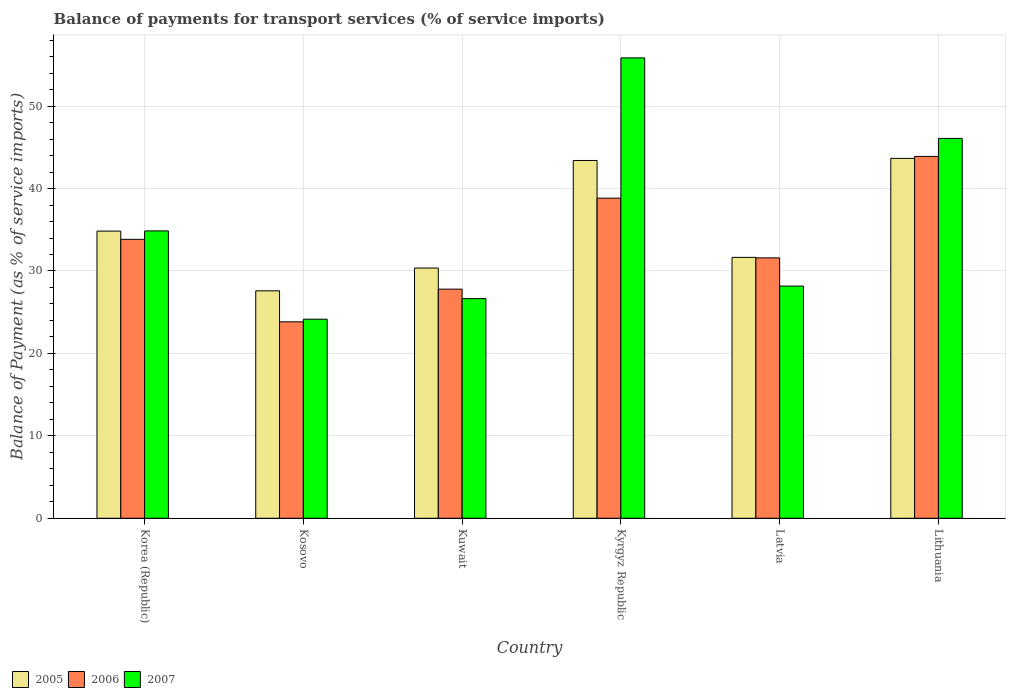How many different coloured bars are there?
Give a very brief answer. 3. Are the number of bars on each tick of the X-axis equal?
Give a very brief answer. Yes. How many bars are there on the 4th tick from the left?
Keep it short and to the point. 3. What is the label of the 5th group of bars from the left?
Make the answer very short. Latvia. What is the balance of payments for transport services in 2007 in Lithuania?
Offer a terse response. 46.08. Across all countries, what is the maximum balance of payments for transport services in 2006?
Your answer should be very brief. 43.9. Across all countries, what is the minimum balance of payments for transport services in 2005?
Give a very brief answer. 27.59. In which country was the balance of payments for transport services in 2005 maximum?
Your answer should be very brief. Lithuania. In which country was the balance of payments for transport services in 2005 minimum?
Make the answer very short. Kosovo. What is the total balance of payments for transport services in 2006 in the graph?
Offer a terse response. 199.79. What is the difference between the balance of payments for transport services in 2005 in Kosovo and that in Latvia?
Provide a succinct answer. -4.06. What is the difference between the balance of payments for transport services in 2005 in Kyrgyz Republic and the balance of payments for transport services in 2007 in Kuwait?
Your answer should be compact. 16.76. What is the average balance of payments for transport services in 2007 per country?
Keep it short and to the point. 35.96. What is the difference between the balance of payments for transport services of/in 2005 and balance of payments for transport services of/in 2007 in Kuwait?
Provide a short and direct response. 3.71. In how many countries, is the balance of payments for transport services in 2005 greater than 54 %?
Make the answer very short. 0. What is the ratio of the balance of payments for transport services in 2006 in Kosovo to that in Lithuania?
Your answer should be very brief. 0.54. Is the difference between the balance of payments for transport services in 2005 in Korea (Republic) and Kosovo greater than the difference between the balance of payments for transport services in 2007 in Korea (Republic) and Kosovo?
Your answer should be compact. No. What is the difference between the highest and the second highest balance of payments for transport services in 2006?
Make the answer very short. -10.06. What is the difference between the highest and the lowest balance of payments for transport services in 2005?
Keep it short and to the point. 16.07. What is the difference between two consecutive major ticks on the Y-axis?
Provide a short and direct response. 10. Are the values on the major ticks of Y-axis written in scientific E-notation?
Your answer should be compact. No. Does the graph contain any zero values?
Give a very brief answer. No. Does the graph contain grids?
Your answer should be compact. Yes. How many legend labels are there?
Ensure brevity in your answer.  3. How are the legend labels stacked?
Provide a short and direct response. Horizontal. What is the title of the graph?
Offer a very short reply. Balance of payments for transport services (% of service imports). What is the label or title of the Y-axis?
Give a very brief answer. Balance of Payment (as % of service imports). What is the Balance of Payment (as % of service imports) of 2005 in Korea (Republic)?
Ensure brevity in your answer.  34.84. What is the Balance of Payment (as % of service imports) of 2006 in Korea (Republic)?
Keep it short and to the point. 33.84. What is the Balance of Payment (as % of service imports) in 2007 in Korea (Republic)?
Give a very brief answer. 34.86. What is the Balance of Payment (as % of service imports) of 2005 in Kosovo?
Your answer should be compact. 27.59. What is the Balance of Payment (as % of service imports) of 2006 in Kosovo?
Make the answer very short. 23.83. What is the Balance of Payment (as % of service imports) of 2007 in Kosovo?
Offer a very short reply. 24.15. What is the Balance of Payment (as % of service imports) of 2005 in Kuwait?
Offer a terse response. 30.36. What is the Balance of Payment (as % of service imports) in 2006 in Kuwait?
Provide a succinct answer. 27.8. What is the Balance of Payment (as % of service imports) of 2007 in Kuwait?
Ensure brevity in your answer.  26.65. What is the Balance of Payment (as % of service imports) in 2005 in Kyrgyz Republic?
Offer a very short reply. 43.41. What is the Balance of Payment (as % of service imports) in 2006 in Kyrgyz Republic?
Ensure brevity in your answer.  38.83. What is the Balance of Payment (as % of service imports) of 2007 in Kyrgyz Republic?
Keep it short and to the point. 55.85. What is the Balance of Payment (as % of service imports) in 2005 in Latvia?
Your answer should be compact. 31.65. What is the Balance of Payment (as % of service imports) of 2006 in Latvia?
Make the answer very short. 31.59. What is the Balance of Payment (as % of service imports) of 2007 in Latvia?
Offer a very short reply. 28.17. What is the Balance of Payment (as % of service imports) of 2005 in Lithuania?
Keep it short and to the point. 43.66. What is the Balance of Payment (as % of service imports) in 2006 in Lithuania?
Keep it short and to the point. 43.9. What is the Balance of Payment (as % of service imports) of 2007 in Lithuania?
Give a very brief answer. 46.08. Across all countries, what is the maximum Balance of Payment (as % of service imports) in 2005?
Ensure brevity in your answer.  43.66. Across all countries, what is the maximum Balance of Payment (as % of service imports) in 2006?
Offer a very short reply. 43.9. Across all countries, what is the maximum Balance of Payment (as % of service imports) in 2007?
Your answer should be compact. 55.85. Across all countries, what is the minimum Balance of Payment (as % of service imports) in 2005?
Provide a short and direct response. 27.59. Across all countries, what is the minimum Balance of Payment (as % of service imports) of 2006?
Keep it short and to the point. 23.83. Across all countries, what is the minimum Balance of Payment (as % of service imports) in 2007?
Offer a terse response. 24.15. What is the total Balance of Payment (as % of service imports) of 2005 in the graph?
Provide a succinct answer. 211.51. What is the total Balance of Payment (as % of service imports) in 2006 in the graph?
Your answer should be very brief. 199.79. What is the total Balance of Payment (as % of service imports) of 2007 in the graph?
Provide a succinct answer. 215.76. What is the difference between the Balance of Payment (as % of service imports) of 2005 in Korea (Republic) and that in Kosovo?
Give a very brief answer. 7.24. What is the difference between the Balance of Payment (as % of service imports) of 2006 in Korea (Republic) and that in Kosovo?
Make the answer very short. 10.01. What is the difference between the Balance of Payment (as % of service imports) in 2007 in Korea (Republic) and that in Kosovo?
Ensure brevity in your answer.  10.71. What is the difference between the Balance of Payment (as % of service imports) in 2005 in Korea (Republic) and that in Kuwait?
Provide a short and direct response. 4.48. What is the difference between the Balance of Payment (as % of service imports) of 2006 in Korea (Republic) and that in Kuwait?
Your answer should be very brief. 6.04. What is the difference between the Balance of Payment (as % of service imports) of 2007 in Korea (Republic) and that in Kuwait?
Provide a short and direct response. 8.21. What is the difference between the Balance of Payment (as % of service imports) in 2005 in Korea (Republic) and that in Kyrgyz Republic?
Offer a very short reply. -8.57. What is the difference between the Balance of Payment (as % of service imports) of 2006 in Korea (Republic) and that in Kyrgyz Republic?
Offer a very short reply. -4.99. What is the difference between the Balance of Payment (as % of service imports) in 2007 in Korea (Republic) and that in Kyrgyz Republic?
Provide a succinct answer. -20.99. What is the difference between the Balance of Payment (as % of service imports) in 2005 in Korea (Republic) and that in Latvia?
Offer a very short reply. 3.19. What is the difference between the Balance of Payment (as % of service imports) in 2006 in Korea (Republic) and that in Latvia?
Keep it short and to the point. 2.25. What is the difference between the Balance of Payment (as % of service imports) of 2007 in Korea (Republic) and that in Latvia?
Give a very brief answer. 6.69. What is the difference between the Balance of Payment (as % of service imports) in 2005 in Korea (Republic) and that in Lithuania?
Your answer should be compact. -8.82. What is the difference between the Balance of Payment (as % of service imports) of 2006 in Korea (Republic) and that in Lithuania?
Ensure brevity in your answer.  -10.06. What is the difference between the Balance of Payment (as % of service imports) in 2007 in Korea (Republic) and that in Lithuania?
Provide a short and direct response. -11.22. What is the difference between the Balance of Payment (as % of service imports) of 2005 in Kosovo and that in Kuwait?
Make the answer very short. -2.76. What is the difference between the Balance of Payment (as % of service imports) in 2006 in Kosovo and that in Kuwait?
Ensure brevity in your answer.  -3.96. What is the difference between the Balance of Payment (as % of service imports) in 2007 in Kosovo and that in Kuwait?
Your answer should be compact. -2.5. What is the difference between the Balance of Payment (as % of service imports) of 2005 in Kosovo and that in Kyrgyz Republic?
Offer a terse response. -15.81. What is the difference between the Balance of Payment (as % of service imports) in 2006 in Kosovo and that in Kyrgyz Republic?
Keep it short and to the point. -15. What is the difference between the Balance of Payment (as % of service imports) of 2007 in Kosovo and that in Kyrgyz Republic?
Keep it short and to the point. -31.7. What is the difference between the Balance of Payment (as % of service imports) in 2005 in Kosovo and that in Latvia?
Your response must be concise. -4.06. What is the difference between the Balance of Payment (as % of service imports) in 2006 in Kosovo and that in Latvia?
Offer a very short reply. -7.76. What is the difference between the Balance of Payment (as % of service imports) in 2007 in Kosovo and that in Latvia?
Keep it short and to the point. -4.02. What is the difference between the Balance of Payment (as % of service imports) in 2005 in Kosovo and that in Lithuania?
Your response must be concise. -16.07. What is the difference between the Balance of Payment (as % of service imports) of 2006 in Kosovo and that in Lithuania?
Provide a short and direct response. -20.07. What is the difference between the Balance of Payment (as % of service imports) of 2007 in Kosovo and that in Lithuania?
Provide a succinct answer. -21.93. What is the difference between the Balance of Payment (as % of service imports) of 2005 in Kuwait and that in Kyrgyz Republic?
Give a very brief answer. -13.05. What is the difference between the Balance of Payment (as % of service imports) in 2006 in Kuwait and that in Kyrgyz Republic?
Offer a very short reply. -11.04. What is the difference between the Balance of Payment (as % of service imports) in 2007 in Kuwait and that in Kyrgyz Republic?
Your answer should be very brief. -29.2. What is the difference between the Balance of Payment (as % of service imports) of 2005 in Kuwait and that in Latvia?
Your answer should be compact. -1.29. What is the difference between the Balance of Payment (as % of service imports) in 2006 in Kuwait and that in Latvia?
Ensure brevity in your answer.  -3.79. What is the difference between the Balance of Payment (as % of service imports) of 2007 in Kuwait and that in Latvia?
Provide a short and direct response. -1.52. What is the difference between the Balance of Payment (as % of service imports) of 2005 in Kuwait and that in Lithuania?
Your answer should be compact. -13.3. What is the difference between the Balance of Payment (as % of service imports) of 2006 in Kuwait and that in Lithuania?
Keep it short and to the point. -16.1. What is the difference between the Balance of Payment (as % of service imports) of 2007 in Kuwait and that in Lithuania?
Ensure brevity in your answer.  -19.43. What is the difference between the Balance of Payment (as % of service imports) of 2005 in Kyrgyz Republic and that in Latvia?
Provide a short and direct response. 11.75. What is the difference between the Balance of Payment (as % of service imports) of 2006 in Kyrgyz Republic and that in Latvia?
Offer a terse response. 7.24. What is the difference between the Balance of Payment (as % of service imports) of 2007 in Kyrgyz Republic and that in Latvia?
Provide a succinct answer. 27.68. What is the difference between the Balance of Payment (as % of service imports) of 2005 in Kyrgyz Republic and that in Lithuania?
Offer a terse response. -0.25. What is the difference between the Balance of Payment (as % of service imports) of 2006 in Kyrgyz Republic and that in Lithuania?
Ensure brevity in your answer.  -5.07. What is the difference between the Balance of Payment (as % of service imports) of 2007 in Kyrgyz Republic and that in Lithuania?
Your response must be concise. 9.77. What is the difference between the Balance of Payment (as % of service imports) of 2005 in Latvia and that in Lithuania?
Make the answer very short. -12.01. What is the difference between the Balance of Payment (as % of service imports) in 2006 in Latvia and that in Lithuania?
Your response must be concise. -12.31. What is the difference between the Balance of Payment (as % of service imports) in 2007 in Latvia and that in Lithuania?
Keep it short and to the point. -17.91. What is the difference between the Balance of Payment (as % of service imports) of 2005 in Korea (Republic) and the Balance of Payment (as % of service imports) of 2006 in Kosovo?
Your response must be concise. 11. What is the difference between the Balance of Payment (as % of service imports) of 2005 in Korea (Republic) and the Balance of Payment (as % of service imports) of 2007 in Kosovo?
Ensure brevity in your answer.  10.69. What is the difference between the Balance of Payment (as % of service imports) in 2006 in Korea (Republic) and the Balance of Payment (as % of service imports) in 2007 in Kosovo?
Your response must be concise. 9.69. What is the difference between the Balance of Payment (as % of service imports) in 2005 in Korea (Republic) and the Balance of Payment (as % of service imports) in 2006 in Kuwait?
Your answer should be very brief. 7.04. What is the difference between the Balance of Payment (as % of service imports) in 2005 in Korea (Republic) and the Balance of Payment (as % of service imports) in 2007 in Kuwait?
Your response must be concise. 8.19. What is the difference between the Balance of Payment (as % of service imports) in 2006 in Korea (Republic) and the Balance of Payment (as % of service imports) in 2007 in Kuwait?
Offer a very short reply. 7.19. What is the difference between the Balance of Payment (as % of service imports) in 2005 in Korea (Republic) and the Balance of Payment (as % of service imports) in 2006 in Kyrgyz Republic?
Keep it short and to the point. -3.99. What is the difference between the Balance of Payment (as % of service imports) in 2005 in Korea (Republic) and the Balance of Payment (as % of service imports) in 2007 in Kyrgyz Republic?
Keep it short and to the point. -21.01. What is the difference between the Balance of Payment (as % of service imports) in 2006 in Korea (Republic) and the Balance of Payment (as % of service imports) in 2007 in Kyrgyz Republic?
Your response must be concise. -22.01. What is the difference between the Balance of Payment (as % of service imports) in 2005 in Korea (Republic) and the Balance of Payment (as % of service imports) in 2006 in Latvia?
Ensure brevity in your answer.  3.25. What is the difference between the Balance of Payment (as % of service imports) in 2005 in Korea (Republic) and the Balance of Payment (as % of service imports) in 2007 in Latvia?
Offer a terse response. 6.67. What is the difference between the Balance of Payment (as % of service imports) of 2006 in Korea (Republic) and the Balance of Payment (as % of service imports) of 2007 in Latvia?
Your response must be concise. 5.67. What is the difference between the Balance of Payment (as % of service imports) of 2005 in Korea (Republic) and the Balance of Payment (as % of service imports) of 2006 in Lithuania?
Your answer should be very brief. -9.06. What is the difference between the Balance of Payment (as % of service imports) of 2005 in Korea (Republic) and the Balance of Payment (as % of service imports) of 2007 in Lithuania?
Your answer should be compact. -11.24. What is the difference between the Balance of Payment (as % of service imports) in 2006 in Korea (Republic) and the Balance of Payment (as % of service imports) in 2007 in Lithuania?
Make the answer very short. -12.24. What is the difference between the Balance of Payment (as % of service imports) of 2005 in Kosovo and the Balance of Payment (as % of service imports) of 2006 in Kuwait?
Your answer should be very brief. -0.2. What is the difference between the Balance of Payment (as % of service imports) in 2005 in Kosovo and the Balance of Payment (as % of service imports) in 2007 in Kuwait?
Your answer should be very brief. 0.95. What is the difference between the Balance of Payment (as % of service imports) in 2006 in Kosovo and the Balance of Payment (as % of service imports) in 2007 in Kuwait?
Offer a terse response. -2.81. What is the difference between the Balance of Payment (as % of service imports) of 2005 in Kosovo and the Balance of Payment (as % of service imports) of 2006 in Kyrgyz Republic?
Make the answer very short. -11.24. What is the difference between the Balance of Payment (as % of service imports) of 2005 in Kosovo and the Balance of Payment (as % of service imports) of 2007 in Kyrgyz Republic?
Offer a terse response. -28.26. What is the difference between the Balance of Payment (as % of service imports) of 2006 in Kosovo and the Balance of Payment (as % of service imports) of 2007 in Kyrgyz Republic?
Provide a succinct answer. -32.02. What is the difference between the Balance of Payment (as % of service imports) in 2005 in Kosovo and the Balance of Payment (as % of service imports) in 2006 in Latvia?
Make the answer very short. -4. What is the difference between the Balance of Payment (as % of service imports) of 2005 in Kosovo and the Balance of Payment (as % of service imports) of 2007 in Latvia?
Keep it short and to the point. -0.57. What is the difference between the Balance of Payment (as % of service imports) of 2006 in Kosovo and the Balance of Payment (as % of service imports) of 2007 in Latvia?
Keep it short and to the point. -4.33. What is the difference between the Balance of Payment (as % of service imports) in 2005 in Kosovo and the Balance of Payment (as % of service imports) in 2006 in Lithuania?
Your answer should be very brief. -16.3. What is the difference between the Balance of Payment (as % of service imports) of 2005 in Kosovo and the Balance of Payment (as % of service imports) of 2007 in Lithuania?
Give a very brief answer. -18.49. What is the difference between the Balance of Payment (as % of service imports) in 2006 in Kosovo and the Balance of Payment (as % of service imports) in 2007 in Lithuania?
Offer a terse response. -22.25. What is the difference between the Balance of Payment (as % of service imports) of 2005 in Kuwait and the Balance of Payment (as % of service imports) of 2006 in Kyrgyz Republic?
Provide a short and direct response. -8.48. What is the difference between the Balance of Payment (as % of service imports) of 2005 in Kuwait and the Balance of Payment (as % of service imports) of 2007 in Kyrgyz Republic?
Provide a succinct answer. -25.49. What is the difference between the Balance of Payment (as % of service imports) of 2006 in Kuwait and the Balance of Payment (as % of service imports) of 2007 in Kyrgyz Republic?
Your answer should be very brief. -28.05. What is the difference between the Balance of Payment (as % of service imports) of 2005 in Kuwait and the Balance of Payment (as % of service imports) of 2006 in Latvia?
Ensure brevity in your answer.  -1.23. What is the difference between the Balance of Payment (as % of service imports) of 2005 in Kuwait and the Balance of Payment (as % of service imports) of 2007 in Latvia?
Your answer should be very brief. 2.19. What is the difference between the Balance of Payment (as % of service imports) of 2006 in Kuwait and the Balance of Payment (as % of service imports) of 2007 in Latvia?
Give a very brief answer. -0.37. What is the difference between the Balance of Payment (as % of service imports) of 2005 in Kuwait and the Balance of Payment (as % of service imports) of 2006 in Lithuania?
Ensure brevity in your answer.  -13.54. What is the difference between the Balance of Payment (as % of service imports) of 2005 in Kuwait and the Balance of Payment (as % of service imports) of 2007 in Lithuania?
Give a very brief answer. -15.72. What is the difference between the Balance of Payment (as % of service imports) in 2006 in Kuwait and the Balance of Payment (as % of service imports) in 2007 in Lithuania?
Your answer should be compact. -18.28. What is the difference between the Balance of Payment (as % of service imports) in 2005 in Kyrgyz Republic and the Balance of Payment (as % of service imports) in 2006 in Latvia?
Keep it short and to the point. 11.81. What is the difference between the Balance of Payment (as % of service imports) of 2005 in Kyrgyz Republic and the Balance of Payment (as % of service imports) of 2007 in Latvia?
Your answer should be compact. 15.24. What is the difference between the Balance of Payment (as % of service imports) in 2006 in Kyrgyz Republic and the Balance of Payment (as % of service imports) in 2007 in Latvia?
Your response must be concise. 10.66. What is the difference between the Balance of Payment (as % of service imports) of 2005 in Kyrgyz Republic and the Balance of Payment (as % of service imports) of 2006 in Lithuania?
Your answer should be compact. -0.49. What is the difference between the Balance of Payment (as % of service imports) of 2005 in Kyrgyz Republic and the Balance of Payment (as % of service imports) of 2007 in Lithuania?
Your answer should be compact. -2.68. What is the difference between the Balance of Payment (as % of service imports) in 2006 in Kyrgyz Republic and the Balance of Payment (as % of service imports) in 2007 in Lithuania?
Your answer should be compact. -7.25. What is the difference between the Balance of Payment (as % of service imports) in 2005 in Latvia and the Balance of Payment (as % of service imports) in 2006 in Lithuania?
Offer a terse response. -12.25. What is the difference between the Balance of Payment (as % of service imports) of 2005 in Latvia and the Balance of Payment (as % of service imports) of 2007 in Lithuania?
Keep it short and to the point. -14.43. What is the difference between the Balance of Payment (as % of service imports) in 2006 in Latvia and the Balance of Payment (as % of service imports) in 2007 in Lithuania?
Offer a very short reply. -14.49. What is the average Balance of Payment (as % of service imports) in 2005 per country?
Provide a succinct answer. 35.25. What is the average Balance of Payment (as % of service imports) of 2006 per country?
Give a very brief answer. 33.3. What is the average Balance of Payment (as % of service imports) of 2007 per country?
Offer a very short reply. 35.96. What is the difference between the Balance of Payment (as % of service imports) of 2005 and Balance of Payment (as % of service imports) of 2007 in Korea (Republic)?
Offer a terse response. -0.02. What is the difference between the Balance of Payment (as % of service imports) in 2006 and Balance of Payment (as % of service imports) in 2007 in Korea (Republic)?
Provide a succinct answer. -1.02. What is the difference between the Balance of Payment (as % of service imports) of 2005 and Balance of Payment (as % of service imports) of 2006 in Kosovo?
Provide a succinct answer. 3.76. What is the difference between the Balance of Payment (as % of service imports) in 2005 and Balance of Payment (as % of service imports) in 2007 in Kosovo?
Give a very brief answer. 3.44. What is the difference between the Balance of Payment (as % of service imports) in 2006 and Balance of Payment (as % of service imports) in 2007 in Kosovo?
Provide a succinct answer. -0.32. What is the difference between the Balance of Payment (as % of service imports) of 2005 and Balance of Payment (as % of service imports) of 2006 in Kuwait?
Your response must be concise. 2.56. What is the difference between the Balance of Payment (as % of service imports) of 2005 and Balance of Payment (as % of service imports) of 2007 in Kuwait?
Ensure brevity in your answer.  3.71. What is the difference between the Balance of Payment (as % of service imports) in 2006 and Balance of Payment (as % of service imports) in 2007 in Kuwait?
Your response must be concise. 1.15. What is the difference between the Balance of Payment (as % of service imports) in 2005 and Balance of Payment (as % of service imports) in 2006 in Kyrgyz Republic?
Make the answer very short. 4.57. What is the difference between the Balance of Payment (as % of service imports) in 2005 and Balance of Payment (as % of service imports) in 2007 in Kyrgyz Republic?
Give a very brief answer. -12.44. What is the difference between the Balance of Payment (as % of service imports) in 2006 and Balance of Payment (as % of service imports) in 2007 in Kyrgyz Republic?
Provide a succinct answer. -17.02. What is the difference between the Balance of Payment (as % of service imports) in 2005 and Balance of Payment (as % of service imports) in 2006 in Latvia?
Your answer should be compact. 0.06. What is the difference between the Balance of Payment (as % of service imports) in 2005 and Balance of Payment (as % of service imports) in 2007 in Latvia?
Offer a terse response. 3.48. What is the difference between the Balance of Payment (as % of service imports) of 2006 and Balance of Payment (as % of service imports) of 2007 in Latvia?
Your answer should be very brief. 3.42. What is the difference between the Balance of Payment (as % of service imports) in 2005 and Balance of Payment (as % of service imports) in 2006 in Lithuania?
Offer a terse response. -0.24. What is the difference between the Balance of Payment (as % of service imports) in 2005 and Balance of Payment (as % of service imports) in 2007 in Lithuania?
Offer a very short reply. -2.42. What is the difference between the Balance of Payment (as % of service imports) of 2006 and Balance of Payment (as % of service imports) of 2007 in Lithuania?
Your answer should be compact. -2.18. What is the ratio of the Balance of Payment (as % of service imports) of 2005 in Korea (Republic) to that in Kosovo?
Make the answer very short. 1.26. What is the ratio of the Balance of Payment (as % of service imports) in 2006 in Korea (Republic) to that in Kosovo?
Give a very brief answer. 1.42. What is the ratio of the Balance of Payment (as % of service imports) of 2007 in Korea (Republic) to that in Kosovo?
Provide a short and direct response. 1.44. What is the ratio of the Balance of Payment (as % of service imports) of 2005 in Korea (Republic) to that in Kuwait?
Keep it short and to the point. 1.15. What is the ratio of the Balance of Payment (as % of service imports) in 2006 in Korea (Republic) to that in Kuwait?
Your response must be concise. 1.22. What is the ratio of the Balance of Payment (as % of service imports) in 2007 in Korea (Republic) to that in Kuwait?
Offer a terse response. 1.31. What is the ratio of the Balance of Payment (as % of service imports) of 2005 in Korea (Republic) to that in Kyrgyz Republic?
Keep it short and to the point. 0.8. What is the ratio of the Balance of Payment (as % of service imports) of 2006 in Korea (Republic) to that in Kyrgyz Republic?
Ensure brevity in your answer.  0.87. What is the ratio of the Balance of Payment (as % of service imports) of 2007 in Korea (Republic) to that in Kyrgyz Republic?
Your response must be concise. 0.62. What is the ratio of the Balance of Payment (as % of service imports) of 2005 in Korea (Republic) to that in Latvia?
Provide a short and direct response. 1.1. What is the ratio of the Balance of Payment (as % of service imports) in 2006 in Korea (Republic) to that in Latvia?
Keep it short and to the point. 1.07. What is the ratio of the Balance of Payment (as % of service imports) in 2007 in Korea (Republic) to that in Latvia?
Provide a short and direct response. 1.24. What is the ratio of the Balance of Payment (as % of service imports) of 2005 in Korea (Republic) to that in Lithuania?
Make the answer very short. 0.8. What is the ratio of the Balance of Payment (as % of service imports) of 2006 in Korea (Republic) to that in Lithuania?
Provide a succinct answer. 0.77. What is the ratio of the Balance of Payment (as % of service imports) of 2007 in Korea (Republic) to that in Lithuania?
Your answer should be compact. 0.76. What is the ratio of the Balance of Payment (as % of service imports) of 2005 in Kosovo to that in Kuwait?
Make the answer very short. 0.91. What is the ratio of the Balance of Payment (as % of service imports) in 2006 in Kosovo to that in Kuwait?
Make the answer very short. 0.86. What is the ratio of the Balance of Payment (as % of service imports) in 2007 in Kosovo to that in Kuwait?
Provide a short and direct response. 0.91. What is the ratio of the Balance of Payment (as % of service imports) of 2005 in Kosovo to that in Kyrgyz Republic?
Keep it short and to the point. 0.64. What is the ratio of the Balance of Payment (as % of service imports) of 2006 in Kosovo to that in Kyrgyz Republic?
Ensure brevity in your answer.  0.61. What is the ratio of the Balance of Payment (as % of service imports) in 2007 in Kosovo to that in Kyrgyz Republic?
Give a very brief answer. 0.43. What is the ratio of the Balance of Payment (as % of service imports) of 2005 in Kosovo to that in Latvia?
Your answer should be very brief. 0.87. What is the ratio of the Balance of Payment (as % of service imports) in 2006 in Kosovo to that in Latvia?
Make the answer very short. 0.75. What is the ratio of the Balance of Payment (as % of service imports) of 2007 in Kosovo to that in Latvia?
Give a very brief answer. 0.86. What is the ratio of the Balance of Payment (as % of service imports) of 2005 in Kosovo to that in Lithuania?
Keep it short and to the point. 0.63. What is the ratio of the Balance of Payment (as % of service imports) of 2006 in Kosovo to that in Lithuania?
Your answer should be compact. 0.54. What is the ratio of the Balance of Payment (as % of service imports) in 2007 in Kosovo to that in Lithuania?
Offer a very short reply. 0.52. What is the ratio of the Balance of Payment (as % of service imports) in 2005 in Kuwait to that in Kyrgyz Republic?
Offer a very short reply. 0.7. What is the ratio of the Balance of Payment (as % of service imports) in 2006 in Kuwait to that in Kyrgyz Republic?
Your answer should be compact. 0.72. What is the ratio of the Balance of Payment (as % of service imports) of 2007 in Kuwait to that in Kyrgyz Republic?
Offer a terse response. 0.48. What is the ratio of the Balance of Payment (as % of service imports) in 2005 in Kuwait to that in Latvia?
Keep it short and to the point. 0.96. What is the ratio of the Balance of Payment (as % of service imports) of 2006 in Kuwait to that in Latvia?
Make the answer very short. 0.88. What is the ratio of the Balance of Payment (as % of service imports) in 2007 in Kuwait to that in Latvia?
Offer a very short reply. 0.95. What is the ratio of the Balance of Payment (as % of service imports) of 2005 in Kuwait to that in Lithuania?
Give a very brief answer. 0.7. What is the ratio of the Balance of Payment (as % of service imports) of 2006 in Kuwait to that in Lithuania?
Offer a very short reply. 0.63. What is the ratio of the Balance of Payment (as % of service imports) in 2007 in Kuwait to that in Lithuania?
Offer a terse response. 0.58. What is the ratio of the Balance of Payment (as % of service imports) of 2005 in Kyrgyz Republic to that in Latvia?
Offer a very short reply. 1.37. What is the ratio of the Balance of Payment (as % of service imports) of 2006 in Kyrgyz Republic to that in Latvia?
Give a very brief answer. 1.23. What is the ratio of the Balance of Payment (as % of service imports) of 2007 in Kyrgyz Republic to that in Latvia?
Provide a succinct answer. 1.98. What is the ratio of the Balance of Payment (as % of service imports) in 2006 in Kyrgyz Republic to that in Lithuania?
Your answer should be compact. 0.88. What is the ratio of the Balance of Payment (as % of service imports) in 2007 in Kyrgyz Republic to that in Lithuania?
Ensure brevity in your answer.  1.21. What is the ratio of the Balance of Payment (as % of service imports) in 2005 in Latvia to that in Lithuania?
Provide a short and direct response. 0.72. What is the ratio of the Balance of Payment (as % of service imports) in 2006 in Latvia to that in Lithuania?
Keep it short and to the point. 0.72. What is the ratio of the Balance of Payment (as % of service imports) in 2007 in Latvia to that in Lithuania?
Your answer should be compact. 0.61. What is the difference between the highest and the second highest Balance of Payment (as % of service imports) of 2005?
Give a very brief answer. 0.25. What is the difference between the highest and the second highest Balance of Payment (as % of service imports) of 2006?
Keep it short and to the point. 5.07. What is the difference between the highest and the second highest Balance of Payment (as % of service imports) of 2007?
Your answer should be compact. 9.77. What is the difference between the highest and the lowest Balance of Payment (as % of service imports) in 2005?
Give a very brief answer. 16.07. What is the difference between the highest and the lowest Balance of Payment (as % of service imports) in 2006?
Provide a short and direct response. 20.07. What is the difference between the highest and the lowest Balance of Payment (as % of service imports) of 2007?
Make the answer very short. 31.7. 